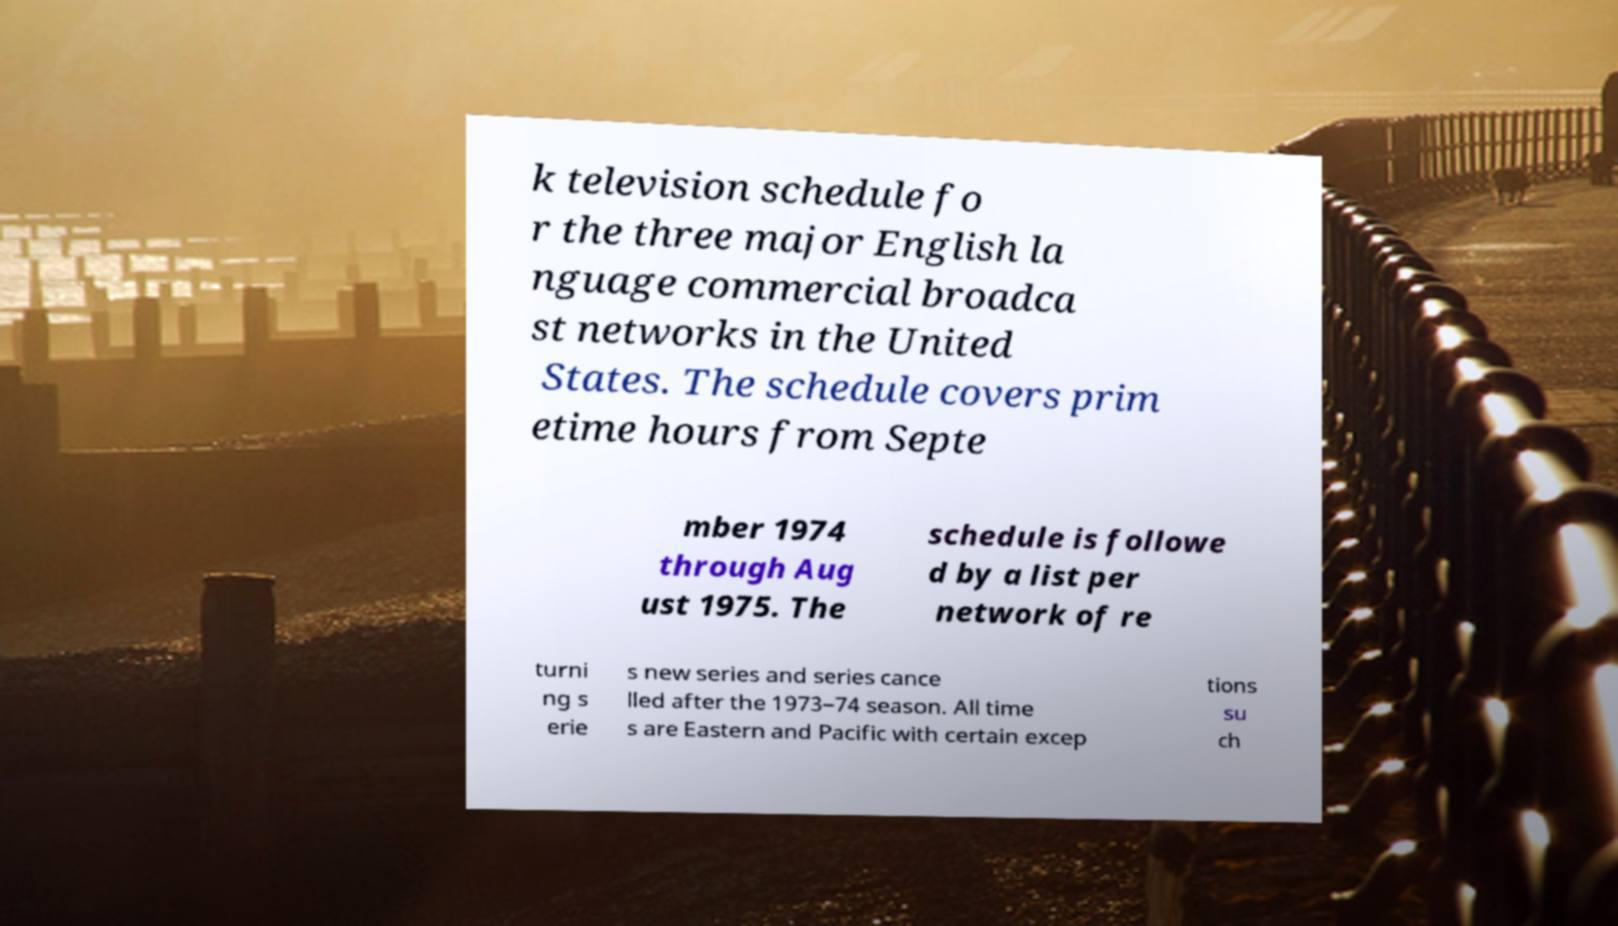I need the written content from this picture converted into text. Can you do that? k television schedule fo r the three major English la nguage commercial broadca st networks in the United States. The schedule covers prim etime hours from Septe mber 1974 through Aug ust 1975. The schedule is followe d by a list per network of re turni ng s erie s new series and series cance lled after the 1973–74 season. All time s are Eastern and Pacific with certain excep tions su ch 